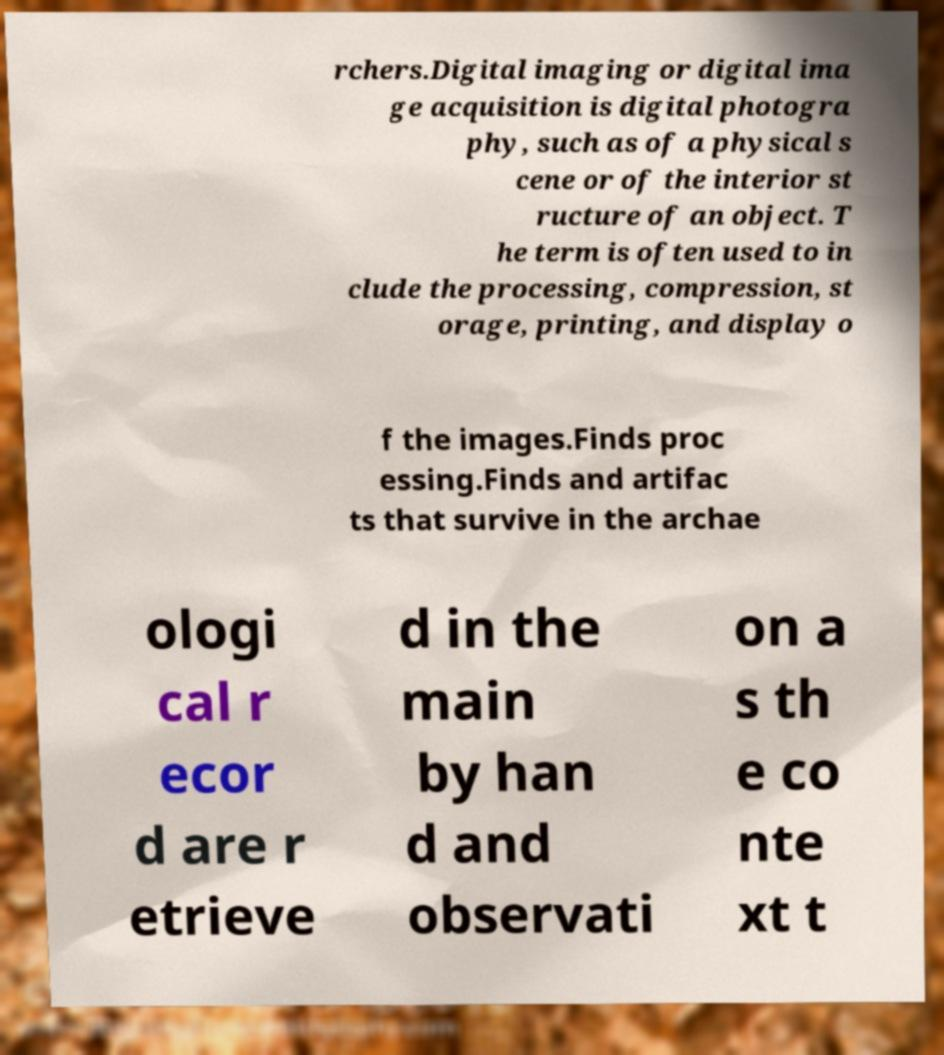I need the written content from this picture converted into text. Can you do that? rchers.Digital imaging or digital ima ge acquisition is digital photogra phy, such as of a physical s cene or of the interior st ructure of an object. T he term is often used to in clude the processing, compression, st orage, printing, and display o f the images.Finds proc essing.Finds and artifac ts that survive in the archae ologi cal r ecor d are r etrieve d in the main by han d and observati on a s th e co nte xt t 